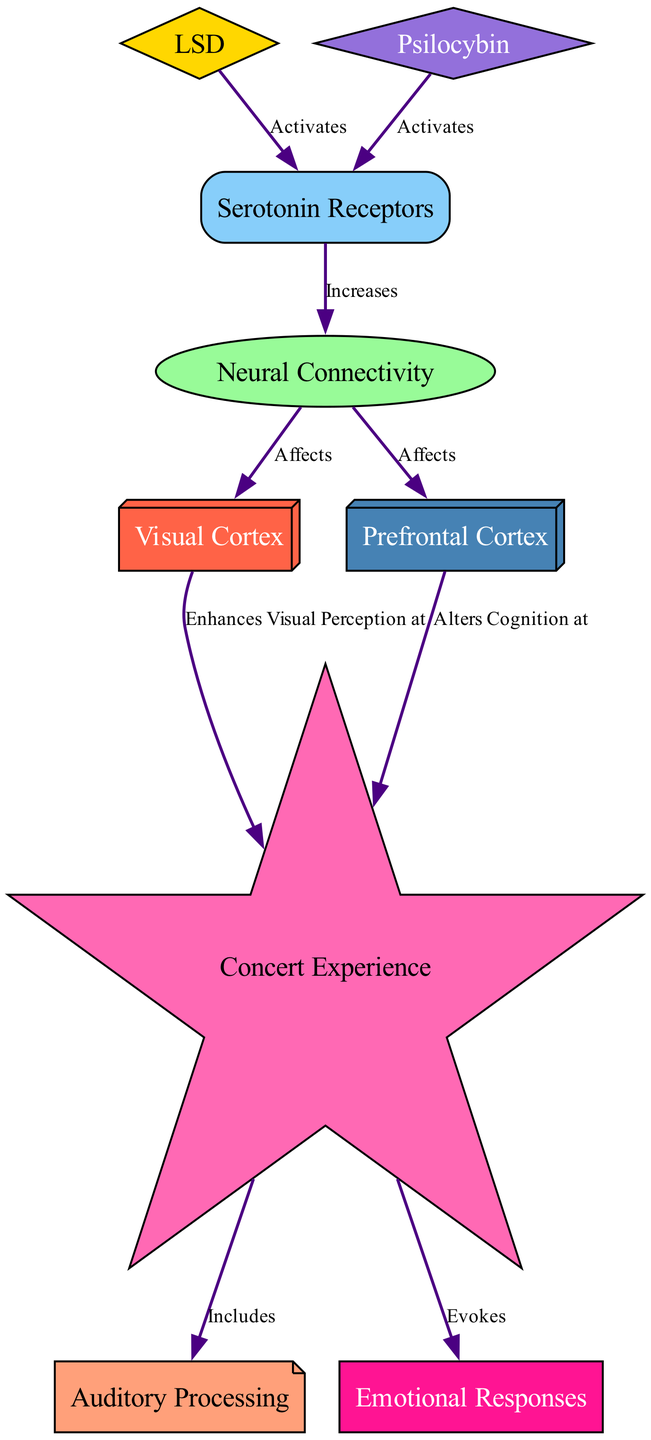What is activated by LSD? The diagram indicates that LSD activates the Serotonin Receptors. By tracing the flow from the node labeled LSD to the node labeled Serotonin Receptors, we see the direct connection representing this activation.
Answer: Serotonin Receptors How many nodes are in the diagram? The diagram includes a total of 9 nodes, which can be counted directly in the visual representation. Each node represents a unique concept related to the impact of psychedelic drugs on brain activity.
Answer: 9 What does Neural Connectivity affect? Neural Connectivity affects both the Visual Cortex and the Prefrontal Cortex, as indicated by the connections leading from Neural Connectivity to these two nodes. The diagram shows arrows leading to both nodes, linking them to Neural Connectivity.
Answer: Visual Cortex and Prefrontal Cortex What experience does the Visual Cortex enhance? The Visual Cortex enhances the Concert Experience, as indicated by the edge connecting Visual Cortex to Concert Experience, which specifies that it enhances visual perception during concerts.
Answer: Concert Experience Which types of emotional components are evoked by the Concert Experience? The Concert Experience evokes Emotional Responses, as shown by the arrow connecting Concert Experience to Emotional Responses in the diagram. This indicates a direct relationship where concert experiences can lead to distinct emotional reactions.
Answer: Emotional Responses What is the relationship between Serotonin Receptors and Neural Connectivity? The diagram shows that Serotonin Receptors increase Neural Connectivity, as indicated by the edge linking the two nodes. This implies that the activation of serotonin receptors leads to an enhancement in how neural connections interact.
Answer: Increases What two areas are affected by Neural Connectivity? Neural Connectivity affects the Visual Cortex and the Prefrontal Cortex, as the diagram shows outgoing edges from Neural Connectivity to both of these nodes. This indicates its dual influence on both cognitive and perceptual aspects.
Answer: Visual Cortex and Prefrontal Cortex What characteristic of the Concert Experience includes Auditory Processing? The edge from Concert Experience to Auditory Processing indicates that the Concert Experience includes Auditory Processing, highlighting the auditory elements involved in the concert experience.
Answer: Auditory Processing How do psychedelics like LSD and Psilocybin interact with Serotonin Receptors? Both LSD and Psilocybin activate Serotonin Receptors, as depicted by the edges linking these substances directly to the Serotonin Receptors node. This common relationship shows their shared mechanism of action in the brain.
Answer: Activates 